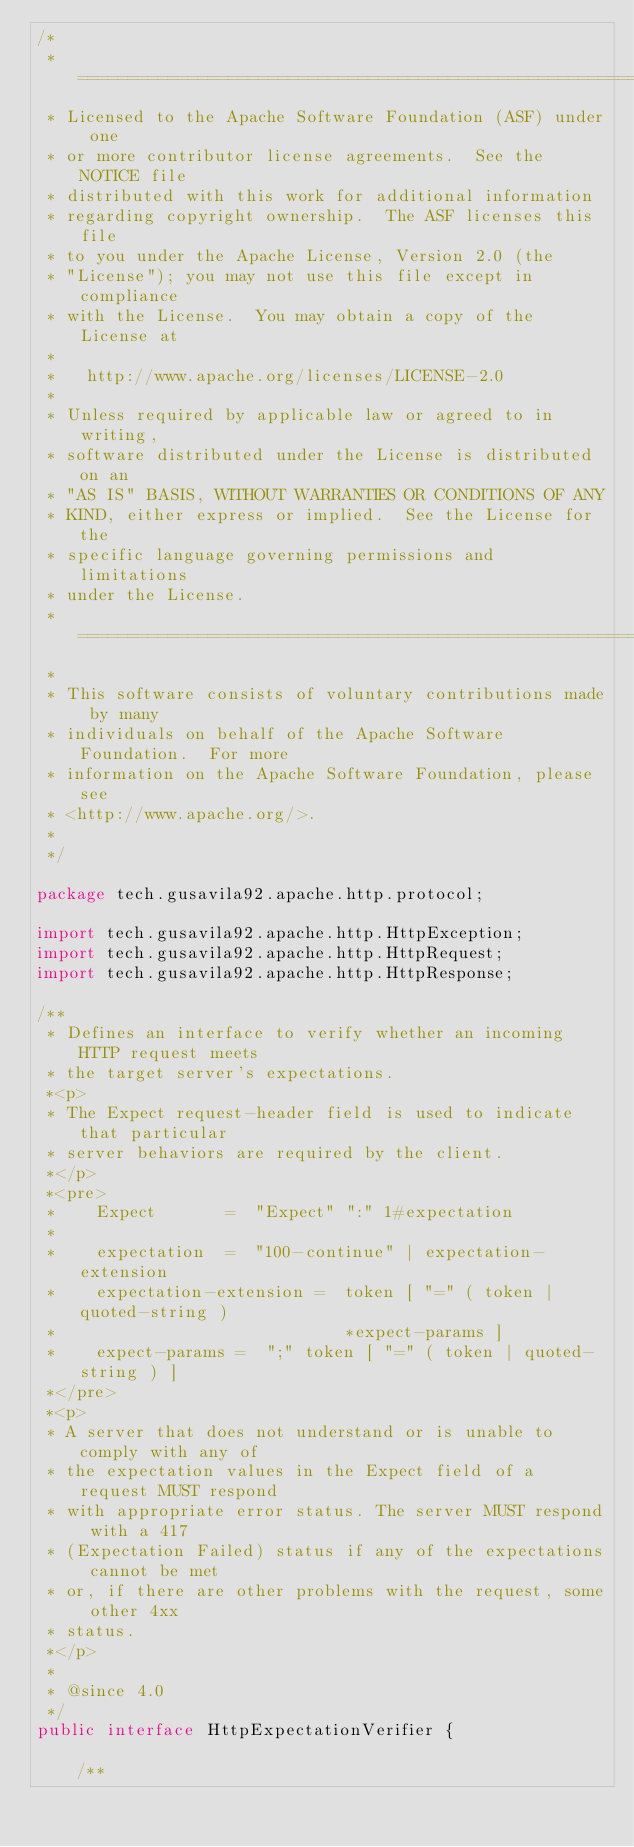<code> <loc_0><loc_0><loc_500><loc_500><_Java_>/*
 * ====================================================================
 * Licensed to the Apache Software Foundation (ASF) under one
 * or more contributor license agreements.  See the NOTICE file
 * distributed with this work for additional information
 * regarding copyright ownership.  The ASF licenses this file
 * to you under the Apache License, Version 2.0 (the
 * "License"); you may not use this file except in compliance
 * with the License.  You may obtain a copy of the License at
 *
 *   http://www.apache.org/licenses/LICENSE-2.0
 *
 * Unless required by applicable law or agreed to in writing,
 * software distributed under the License is distributed on an
 * "AS IS" BASIS, WITHOUT WARRANTIES OR CONDITIONS OF ANY
 * KIND, either express or implied.  See the License for the
 * specific language governing permissions and limitations
 * under the License.
 * ====================================================================
 *
 * This software consists of voluntary contributions made by many
 * individuals on behalf of the Apache Software Foundation.  For more
 * information on the Apache Software Foundation, please see
 * <http://www.apache.org/>.
 *
 */

package tech.gusavila92.apache.http.protocol;

import tech.gusavila92.apache.http.HttpException;
import tech.gusavila92.apache.http.HttpRequest;
import tech.gusavila92.apache.http.HttpResponse;

/**
 * Defines an interface to verify whether an incoming HTTP request meets
 * the target server's expectations.
 *<p>
 * The Expect request-header field is used to indicate that particular
 * server behaviors are required by the client.
 *</p>
 *<pre>
 *    Expect       =  "Expect" ":" 1#expectation
 *
 *    expectation  =  "100-continue" | expectation-extension
 *    expectation-extension =  token [ "=" ( token | quoted-string )
 *                             *expect-params ]
 *    expect-params =  ";" token [ "=" ( token | quoted-string ) ]
 *</pre>
 *<p>
 * A server that does not understand or is unable to comply with any of
 * the expectation values in the Expect field of a request MUST respond
 * with appropriate error status. The server MUST respond with a 417
 * (Expectation Failed) status if any of the expectations cannot be met
 * or, if there are other problems with the request, some other 4xx
 * status.
 *</p>
 *
 * @since 4.0
 */
public interface HttpExpectationVerifier {

    /**</code> 